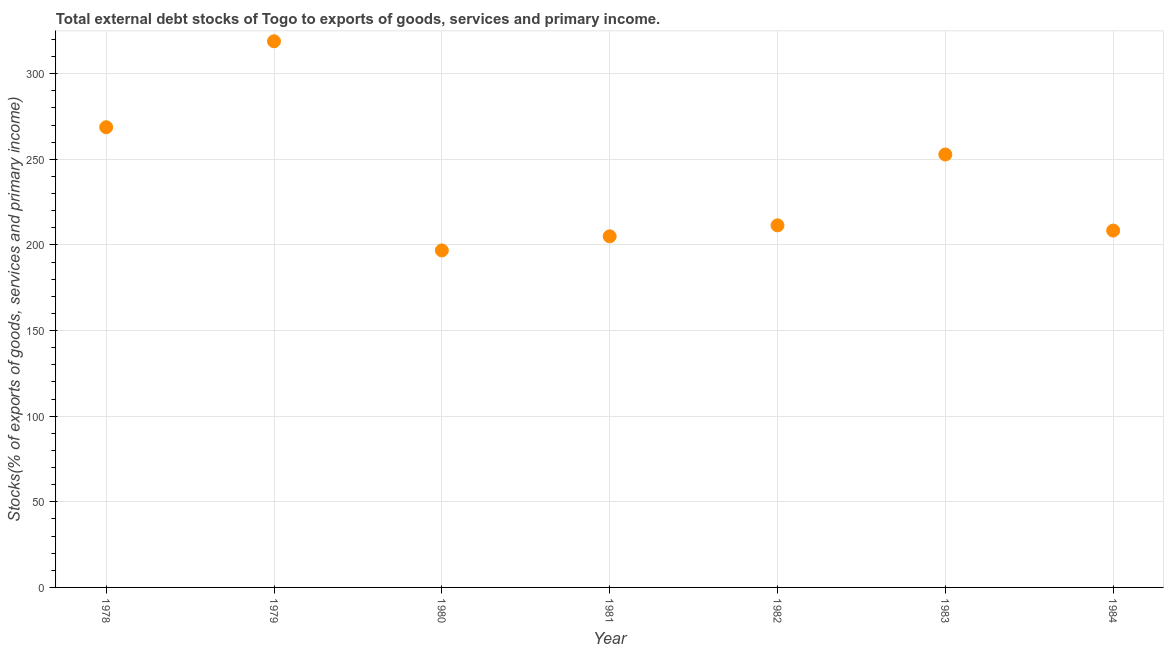What is the external debt stocks in 1978?
Keep it short and to the point. 268.7. Across all years, what is the maximum external debt stocks?
Make the answer very short. 318.89. Across all years, what is the minimum external debt stocks?
Your answer should be very brief. 196.77. In which year was the external debt stocks maximum?
Your response must be concise. 1979. In which year was the external debt stocks minimum?
Your answer should be compact. 1980. What is the sum of the external debt stocks?
Keep it short and to the point. 1661.95. What is the difference between the external debt stocks in 1981 and 1984?
Provide a succinct answer. -3.37. What is the average external debt stocks per year?
Make the answer very short. 237.42. What is the median external debt stocks?
Provide a short and direct response. 211.42. In how many years, is the external debt stocks greater than 280 %?
Your answer should be compact. 1. Do a majority of the years between 1982 and 1981 (inclusive) have external debt stocks greater than 250 %?
Give a very brief answer. No. What is the ratio of the external debt stocks in 1981 to that in 1983?
Make the answer very short. 0.81. What is the difference between the highest and the second highest external debt stocks?
Offer a terse response. 50.18. Is the sum of the external debt stocks in 1979 and 1982 greater than the maximum external debt stocks across all years?
Give a very brief answer. Yes. What is the difference between the highest and the lowest external debt stocks?
Ensure brevity in your answer.  122.12. Does the external debt stocks monotonically increase over the years?
Provide a short and direct response. No. Does the graph contain grids?
Give a very brief answer. Yes. What is the title of the graph?
Offer a terse response. Total external debt stocks of Togo to exports of goods, services and primary income. What is the label or title of the X-axis?
Offer a terse response. Year. What is the label or title of the Y-axis?
Make the answer very short. Stocks(% of exports of goods, services and primary income). What is the Stocks(% of exports of goods, services and primary income) in 1978?
Offer a very short reply. 268.7. What is the Stocks(% of exports of goods, services and primary income) in 1979?
Your answer should be compact. 318.89. What is the Stocks(% of exports of goods, services and primary income) in 1980?
Your response must be concise. 196.77. What is the Stocks(% of exports of goods, services and primary income) in 1981?
Your answer should be compact. 205.01. What is the Stocks(% of exports of goods, services and primary income) in 1982?
Your answer should be very brief. 211.42. What is the Stocks(% of exports of goods, services and primary income) in 1983?
Provide a short and direct response. 252.79. What is the Stocks(% of exports of goods, services and primary income) in 1984?
Give a very brief answer. 208.37. What is the difference between the Stocks(% of exports of goods, services and primary income) in 1978 and 1979?
Your answer should be compact. -50.18. What is the difference between the Stocks(% of exports of goods, services and primary income) in 1978 and 1980?
Your answer should be compact. 71.93. What is the difference between the Stocks(% of exports of goods, services and primary income) in 1978 and 1981?
Provide a succinct answer. 63.7. What is the difference between the Stocks(% of exports of goods, services and primary income) in 1978 and 1982?
Ensure brevity in your answer.  57.29. What is the difference between the Stocks(% of exports of goods, services and primary income) in 1978 and 1983?
Provide a short and direct response. 15.92. What is the difference between the Stocks(% of exports of goods, services and primary income) in 1978 and 1984?
Make the answer very short. 60.33. What is the difference between the Stocks(% of exports of goods, services and primary income) in 1979 and 1980?
Your answer should be very brief. 122.12. What is the difference between the Stocks(% of exports of goods, services and primary income) in 1979 and 1981?
Your answer should be very brief. 113.88. What is the difference between the Stocks(% of exports of goods, services and primary income) in 1979 and 1982?
Provide a succinct answer. 107.47. What is the difference between the Stocks(% of exports of goods, services and primary income) in 1979 and 1983?
Provide a succinct answer. 66.1. What is the difference between the Stocks(% of exports of goods, services and primary income) in 1979 and 1984?
Offer a terse response. 110.52. What is the difference between the Stocks(% of exports of goods, services and primary income) in 1980 and 1981?
Your answer should be very brief. -8.24. What is the difference between the Stocks(% of exports of goods, services and primary income) in 1980 and 1982?
Give a very brief answer. -14.65. What is the difference between the Stocks(% of exports of goods, services and primary income) in 1980 and 1983?
Provide a short and direct response. -56.02. What is the difference between the Stocks(% of exports of goods, services and primary income) in 1980 and 1984?
Ensure brevity in your answer.  -11.6. What is the difference between the Stocks(% of exports of goods, services and primary income) in 1981 and 1982?
Make the answer very short. -6.41. What is the difference between the Stocks(% of exports of goods, services and primary income) in 1981 and 1983?
Offer a very short reply. -47.78. What is the difference between the Stocks(% of exports of goods, services and primary income) in 1981 and 1984?
Give a very brief answer. -3.37. What is the difference between the Stocks(% of exports of goods, services and primary income) in 1982 and 1983?
Offer a terse response. -41.37. What is the difference between the Stocks(% of exports of goods, services and primary income) in 1982 and 1984?
Provide a succinct answer. 3.05. What is the difference between the Stocks(% of exports of goods, services and primary income) in 1983 and 1984?
Your answer should be compact. 44.42. What is the ratio of the Stocks(% of exports of goods, services and primary income) in 1978 to that in 1979?
Your response must be concise. 0.84. What is the ratio of the Stocks(% of exports of goods, services and primary income) in 1978 to that in 1980?
Offer a very short reply. 1.37. What is the ratio of the Stocks(% of exports of goods, services and primary income) in 1978 to that in 1981?
Your answer should be very brief. 1.31. What is the ratio of the Stocks(% of exports of goods, services and primary income) in 1978 to that in 1982?
Your answer should be compact. 1.27. What is the ratio of the Stocks(% of exports of goods, services and primary income) in 1978 to that in 1983?
Your response must be concise. 1.06. What is the ratio of the Stocks(% of exports of goods, services and primary income) in 1978 to that in 1984?
Give a very brief answer. 1.29. What is the ratio of the Stocks(% of exports of goods, services and primary income) in 1979 to that in 1980?
Provide a short and direct response. 1.62. What is the ratio of the Stocks(% of exports of goods, services and primary income) in 1979 to that in 1981?
Ensure brevity in your answer.  1.56. What is the ratio of the Stocks(% of exports of goods, services and primary income) in 1979 to that in 1982?
Your response must be concise. 1.51. What is the ratio of the Stocks(% of exports of goods, services and primary income) in 1979 to that in 1983?
Your answer should be compact. 1.26. What is the ratio of the Stocks(% of exports of goods, services and primary income) in 1979 to that in 1984?
Offer a very short reply. 1.53. What is the ratio of the Stocks(% of exports of goods, services and primary income) in 1980 to that in 1982?
Offer a very short reply. 0.93. What is the ratio of the Stocks(% of exports of goods, services and primary income) in 1980 to that in 1983?
Ensure brevity in your answer.  0.78. What is the ratio of the Stocks(% of exports of goods, services and primary income) in 1980 to that in 1984?
Offer a very short reply. 0.94. What is the ratio of the Stocks(% of exports of goods, services and primary income) in 1981 to that in 1983?
Make the answer very short. 0.81. What is the ratio of the Stocks(% of exports of goods, services and primary income) in 1981 to that in 1984?
Keep it short and to the point. 0.98. What is the ratio of the Stocks(% of exports of goods, services and primary income) in 1982 to that in 1983?
Your response must be concise. 0.84. What is the ratio of the Stocks(% of exports of goods, services and primary income) in 1982 to that in 1984?
Ensure brevity in your answer.  1.01. What is the ratio of the Stocks(% of exports of goods, services and primary income) in 1983 to that in 1984?
Make the answer very short. 1.21. 